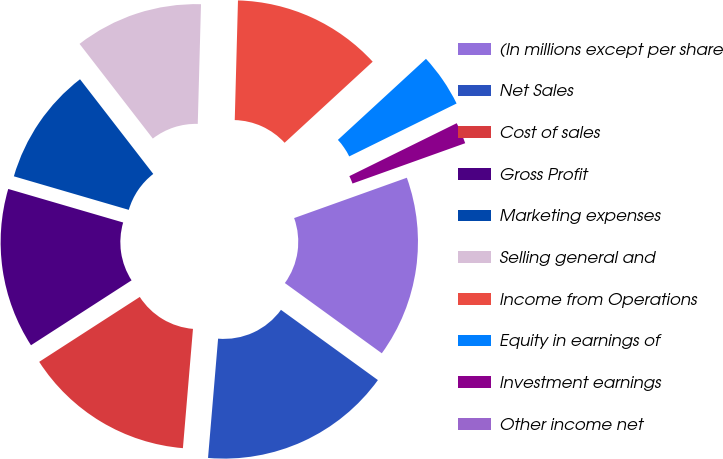Convert chart. <chart><loc_0><loc_0><loc_500><loc_500><pie_chart><fcel>(In millions except per share<fcel>Net Sales<fcel>Cost of sales<fcel>Gross Profit<fcel>Marketing expenses<fcel>Selling general and<fcel>Income from Operations<fcel>Equity in earnings of<fcel>Investment earnings<fcel>Other income net<nl><fcel>15.45%<fcel>16.36%<fcel>14.54%<fcel>13.64%<fcel>10.0%<fcel>10.91%<fcel>12.73%<fcel>4.55%<fcel>1.82%<fcel>0.0%<nl></chart> 